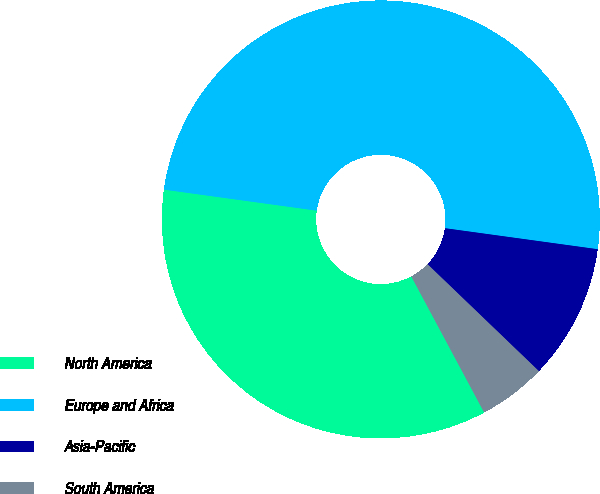<chart> <loc_0><loc_0><loc_500><loc_500><pie_chart><fcel>North America<fcel>Europe and Africa<fcel>Asia-Pacific<fcel>South America<nl><fcel>35.0%<fcel>50.0%<fcel>10.0%<fcel>5.0%<nl></chart> 